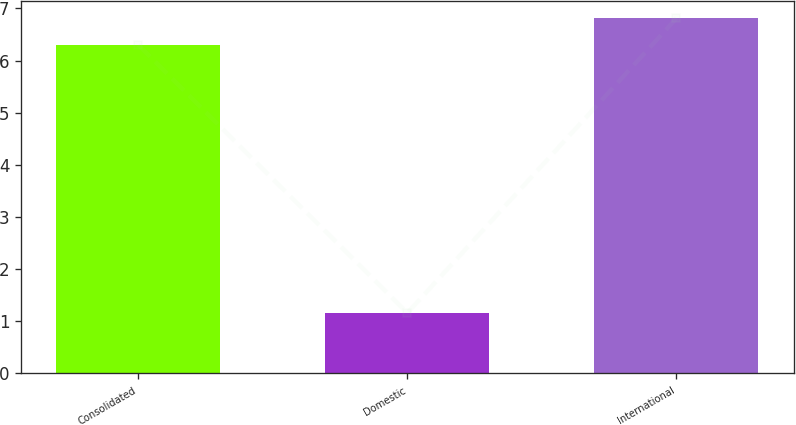<chart> <loc_0><loc_0><loc_500><loc_500><bar_chart><fcel>Consolidated<fcel>Domestic<fcel>International<nl><fcel>6.3<fcel>1.16<fcel>6.81<nl></chart> 